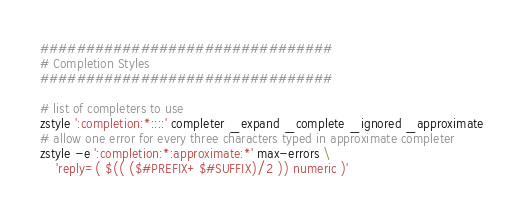Convert code to text. <code><loc_0><loc_0><loc_500><loc_500><_Bash_>################################
# Completion Styles
################################

# list of completers to use
zstyle ':completion:*::::' completer _expand _complete _ignored _approximate
# allow one error for every three characters typed in approximate completer
zstyle -e ':completion:*:approximate:*' max-errors \
    'reply=( $(( ($#PREFIX+$#SUFFIX)/2 )) numeric )'
</code> 